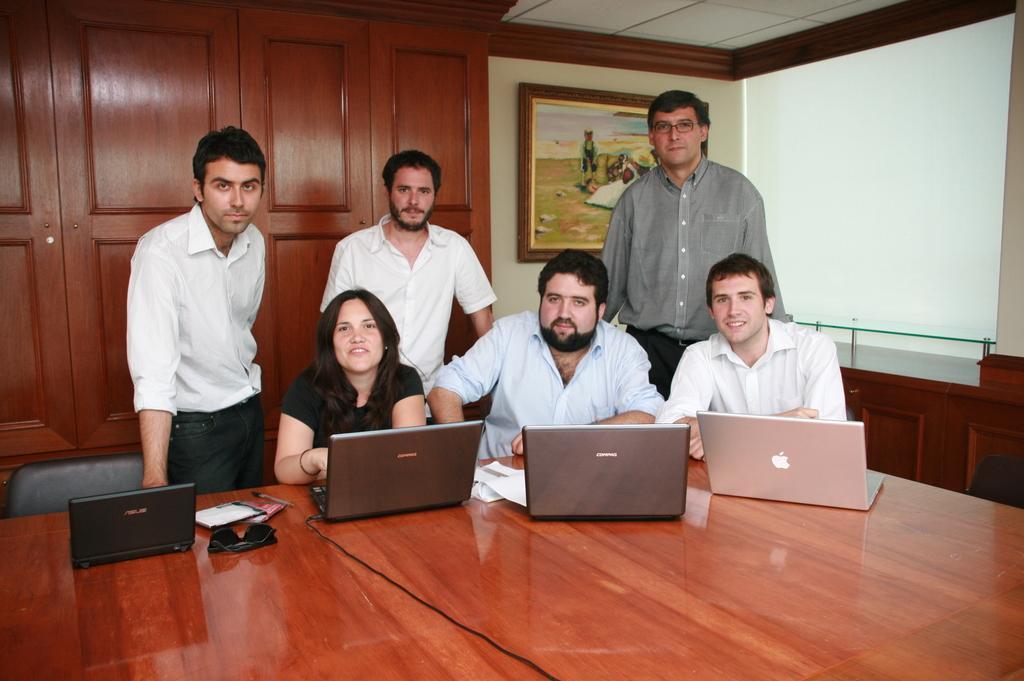Please provide a concise description of this image. In the image there is a table and on the table there are laptops and other objects, behind the tables there are three people sitting on the chairs and behind them there are three people standing, in the background there are cupboards, on the right side there is a wall and there is a photo frame attached to the wall. 